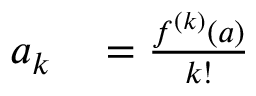Convert formula to latex. <formula><loc_0><loc_0><loc_500><loc_500>\begin{array} { r l } { a _ { k } } & = { \frac { f ^ { ( k ) } ( a ) } { k ! } } } \end{array}</formula> 